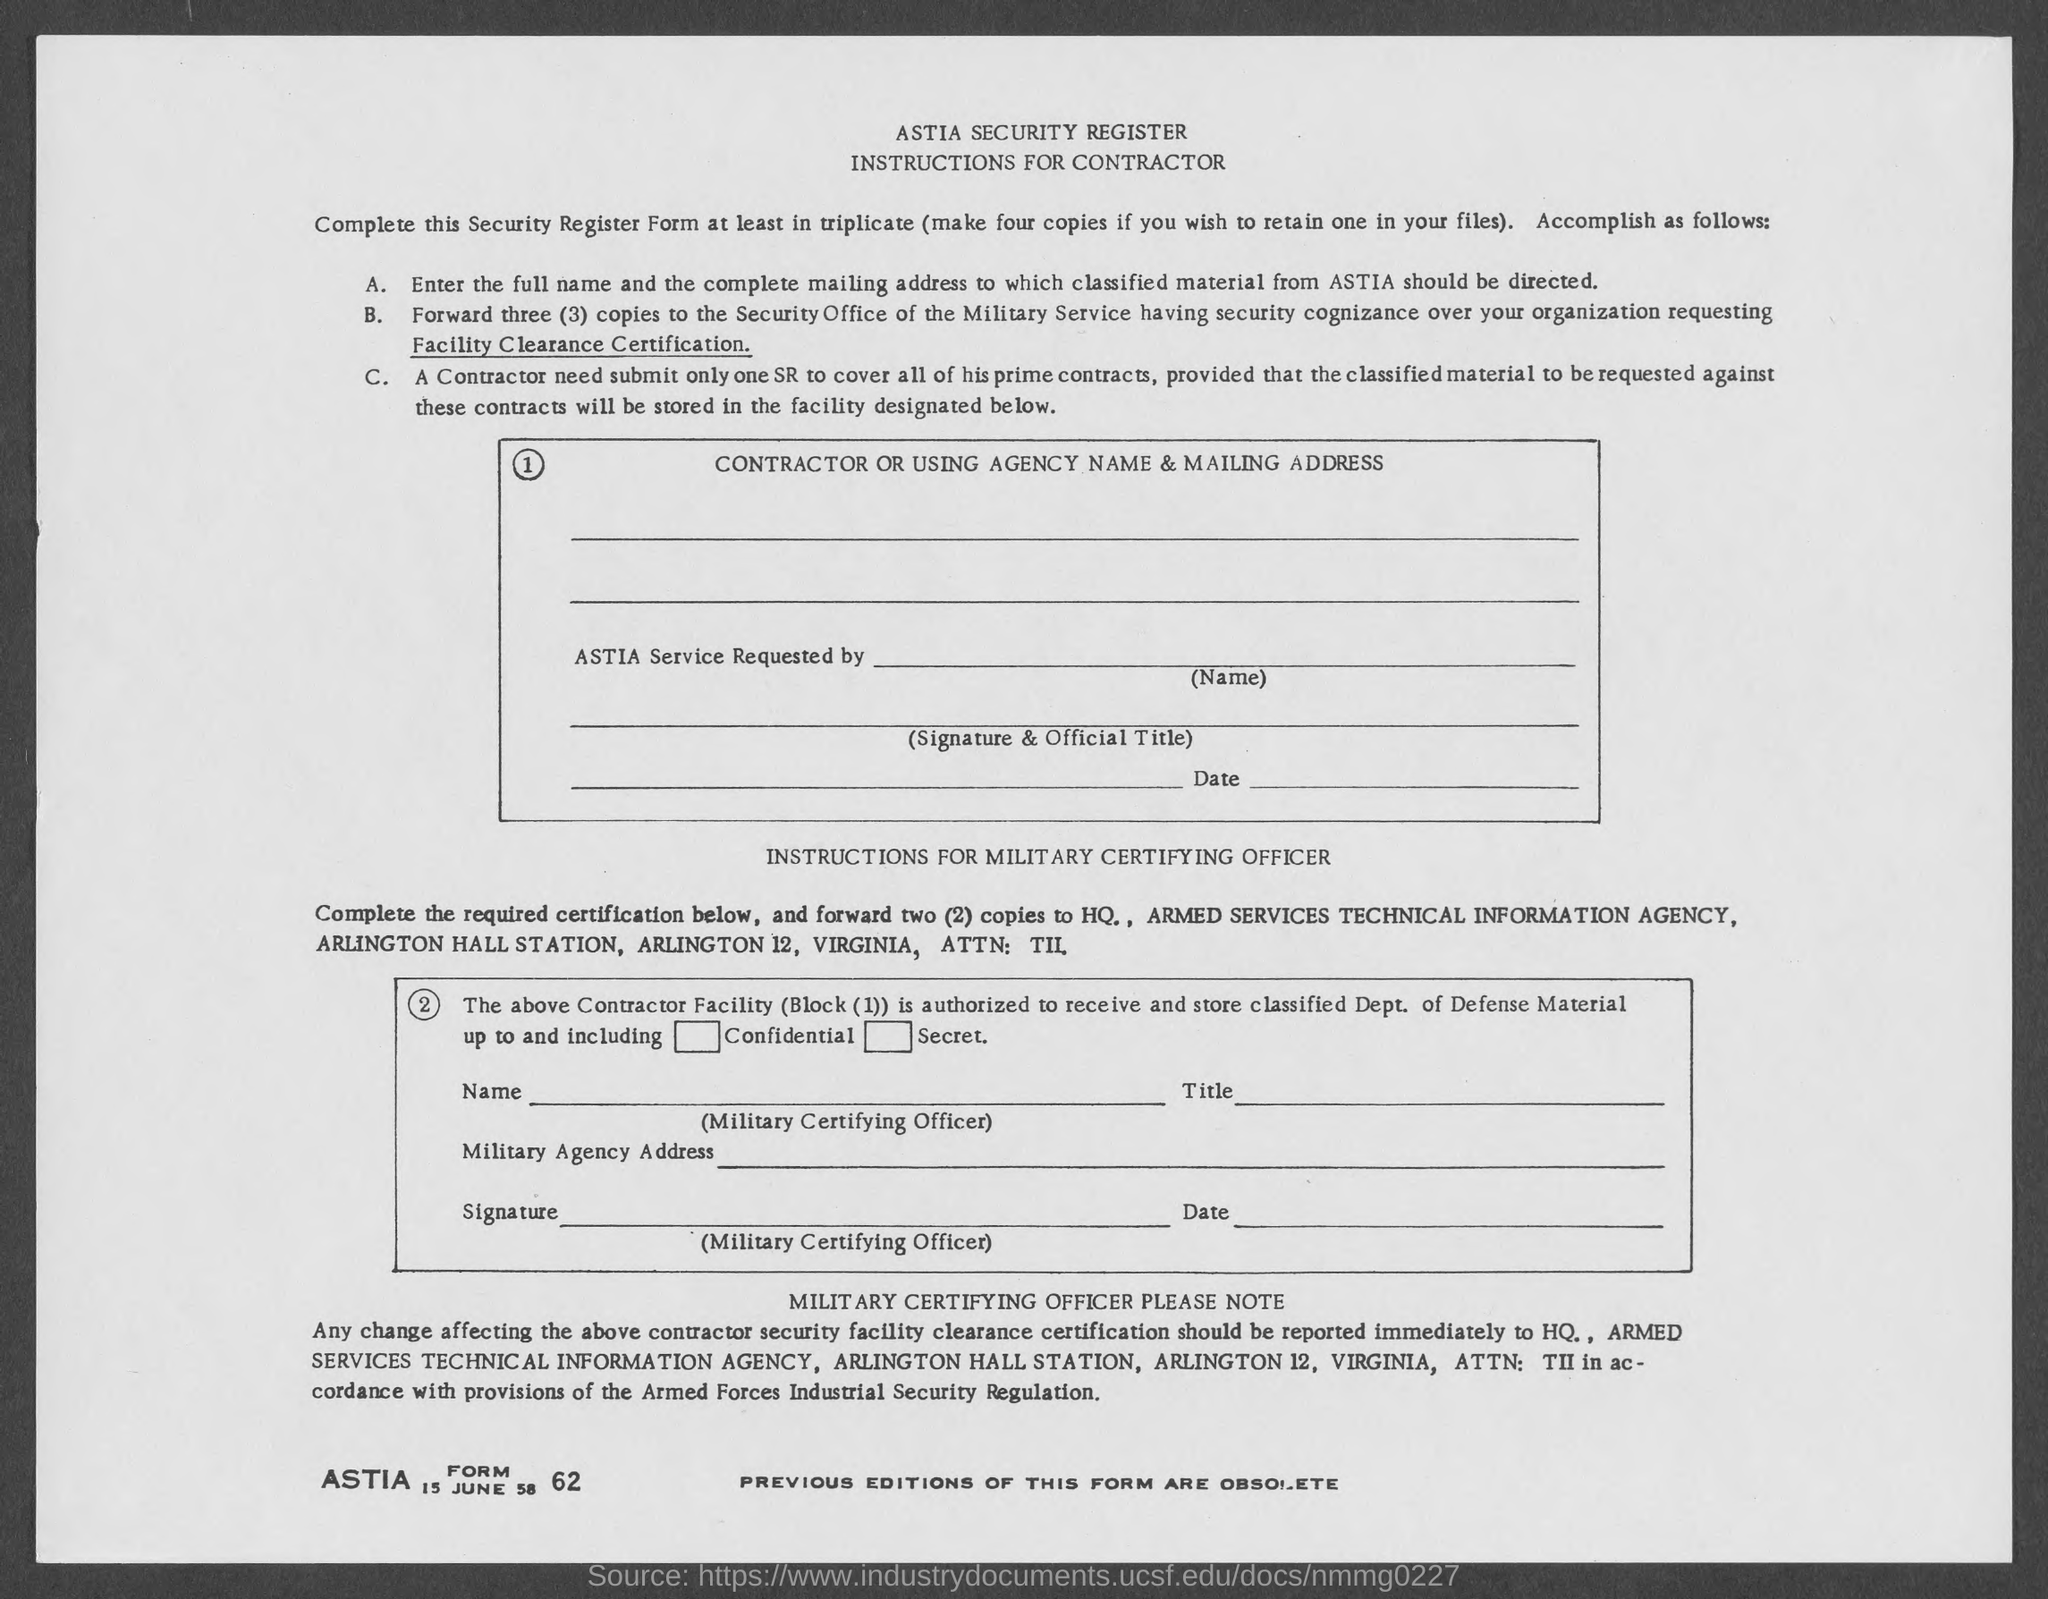What is the ASTIA Form No. given?
Offer a terse response. 62. What is the date mentioned in the form?
Your response must be concise. 15 June 58. What is the fullform of ASTIA?
Make the answer very short. ARMED SERVICES TECHNICAL INFORMATION AGENCY. 